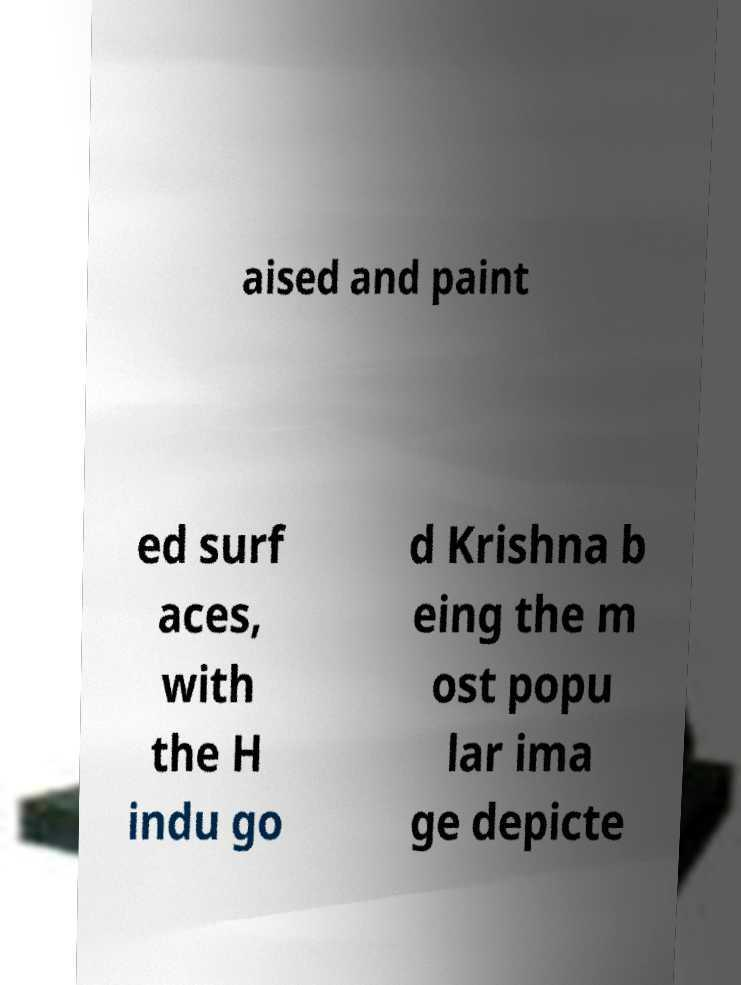Could you extract and type out the text from this image? aised and paint ed surf aces, with the H indu go d Krishna b eing the m ost popu lar ima ge depicte 